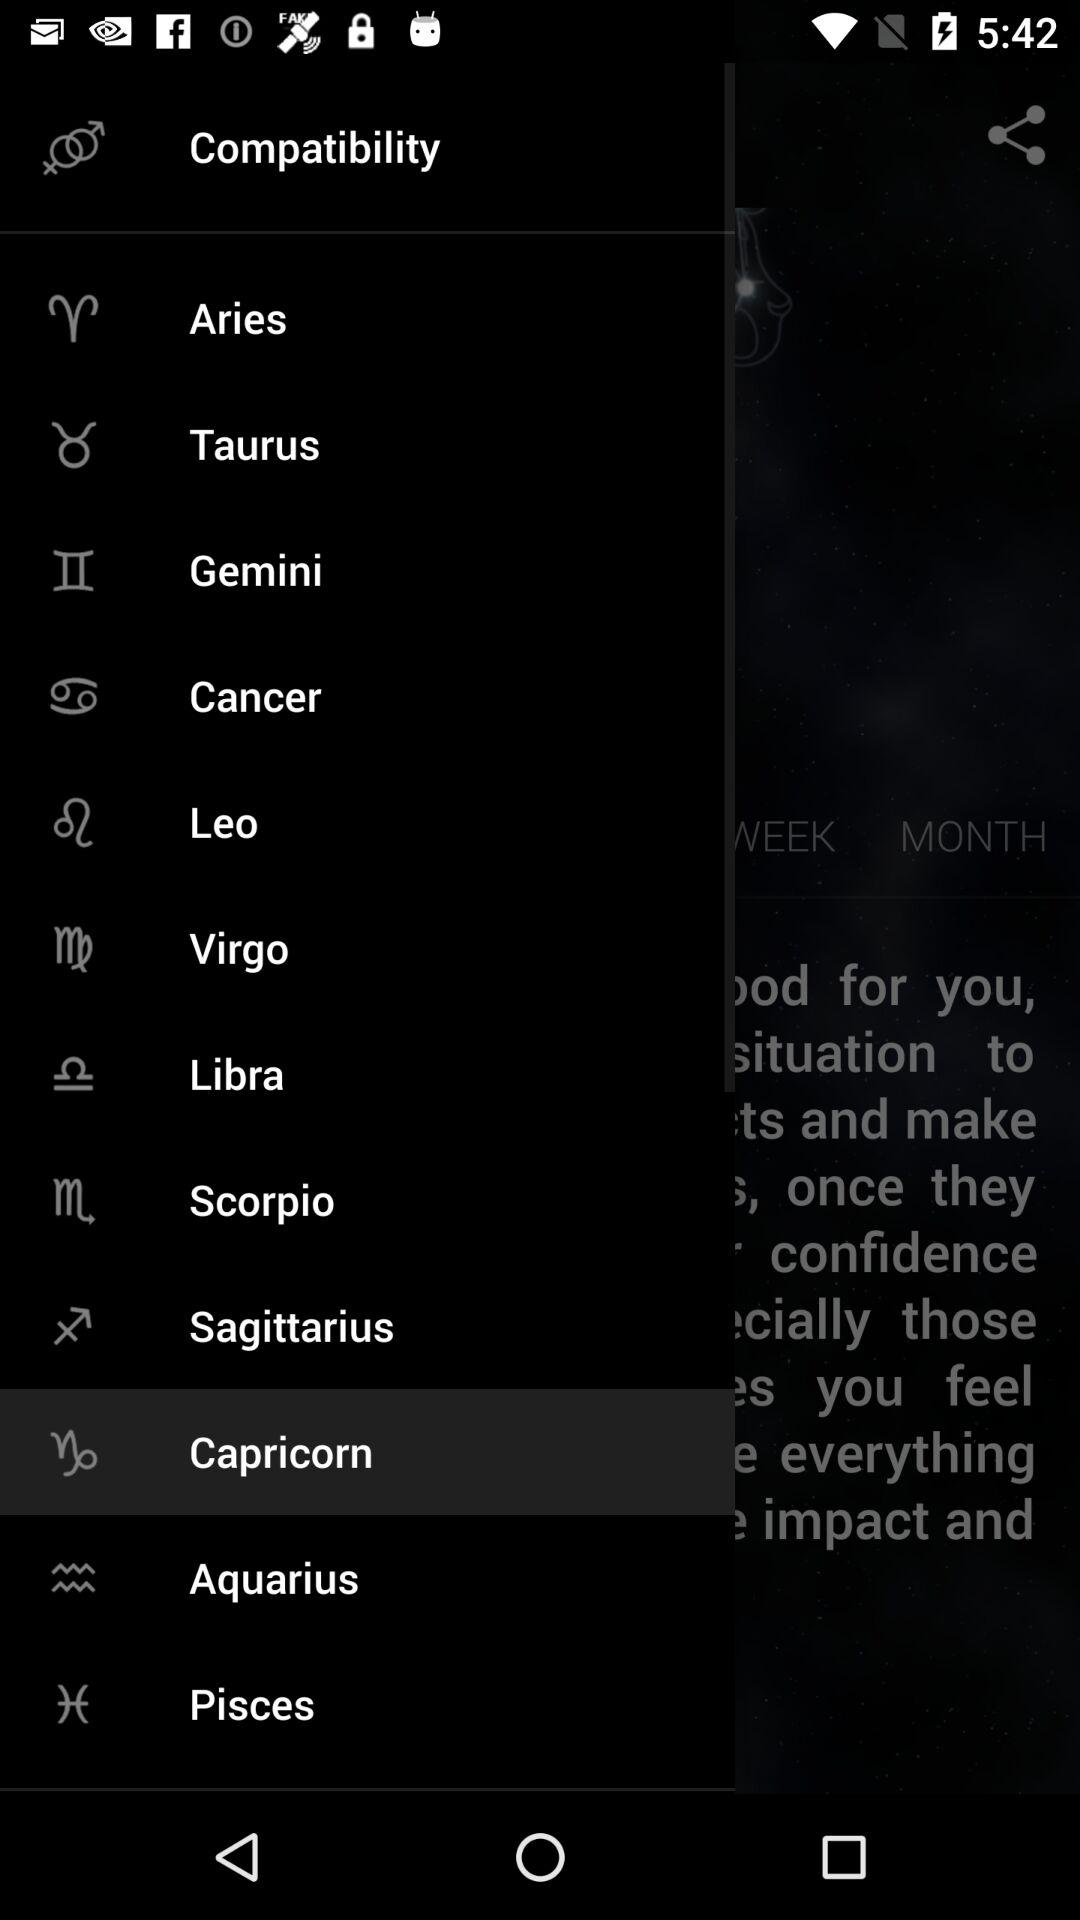Which option is selected? The selected option is "Capricorn". 